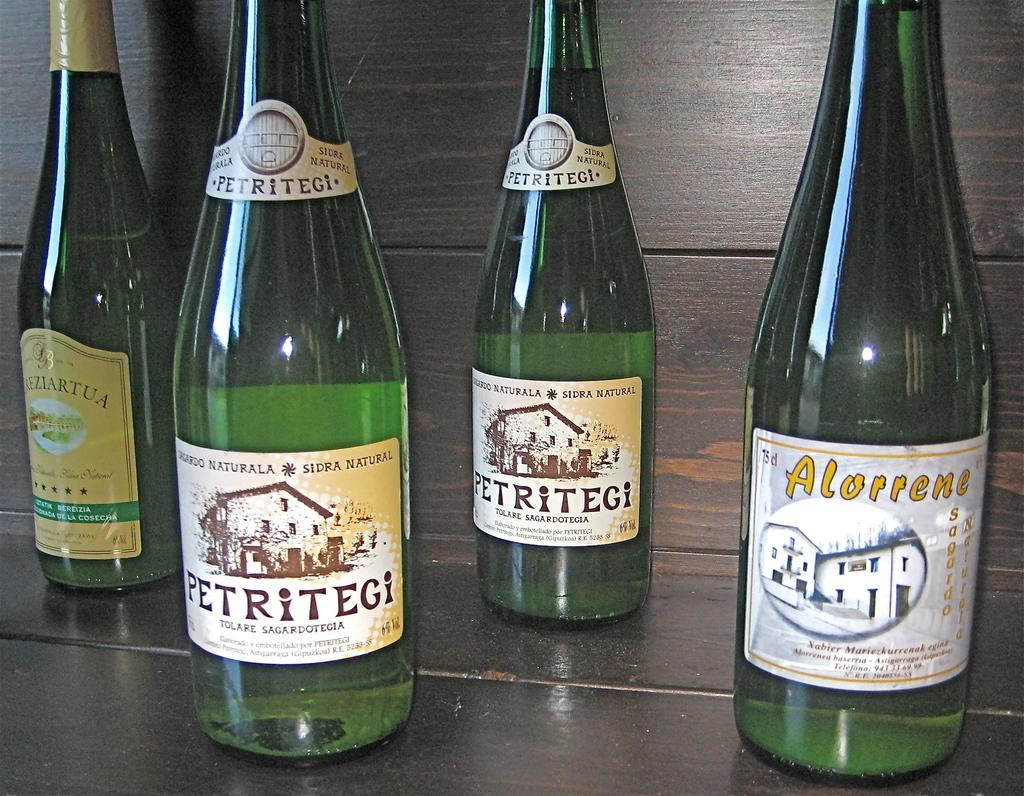<image>
Share a concise interpretation of the image provided. Four unopened bottles of wine, two from Petritegi, and one from Alorrene. 